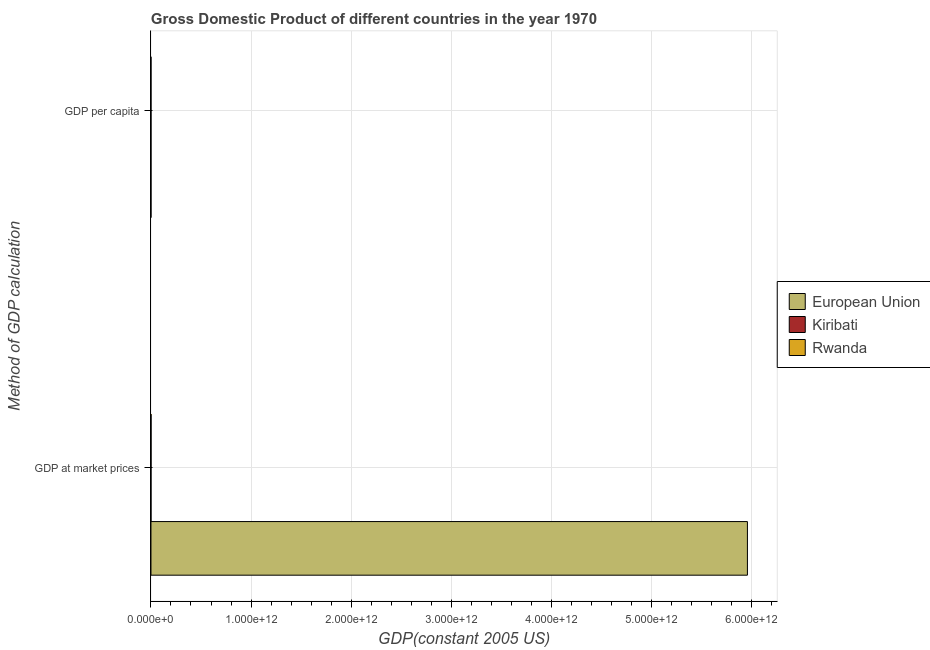How many bars are there on the 2nd tick from the top?
Ensure brevity in your answer.  3. How many bars are there on the 1st tick from the bottom?
Provide a succinct answer. 3. What is the label of the 1st group of bars from the top?
Make the answer very short. GDP per capita. What is the gdp at market prices in European Union?
Give a very brief answer. 5.96e+12. Across all countries, what is the maximum gdp per capita?
Offer a very short reply. 1.35e+04. Across all countries, what is the minimum gdp at market prices?
Your response must be concise. 8.36e+07. In which country was the gdp at market prices maximum?
Offer a terse response. European Union. In which country was the gdp per capita minimum?
Offer a terse response. Rwanda. What is the total gdp per capita in the graph?
Provide a short and direct response. 1.53e+04. What is the difference between the gdp at market prices in European Union and that in Rwanda?
Give a very brief answer. 5.96e+12. What is the difference between the gdp at market prices in European Union and the gdp per capita in Kiribati?
Make the answer very short. 5.96e+12. What is the average gdp at market prices per country?
Keep it short and to the point. 1.99e+12. What is the difference between the gdp per capita and gdp at market prices in Rwanda?
Your answer should be very brief. -8.41e+08. In how many countries, is the gdp per capita greater than 600000000000 US$?
Your response must be concise. 0. What is the ratio of the gdp at market prices in Kiribati to that in Rwanda?
Your answer should be very brief. 0.1. Is the gdp per capita in European Union less than that in Rwanda?
Offer a very short reply. No. What does the 1st bar from the top in GDP at market prices represents?
Make the answer very short. Rwanda. What does the 1st bar from the bottom in GDP at market prices represents?
Offer a terse response. European Union. How many countries are there in the graph?
Give a very brief answer. 3. What is the difference between two consecutive major ticks on the X-axis?
Your response must be concise. 1.00e+12. Are the values on the major ticks of X-axis written in scientific E-notation?
Offer a terse response. Yes. Where does the legend appear in the graph?
Provide a succinct answer. Center right. What is the title of the graph?
Keep it short and to the point. Gross Domestic Product of different countries in the year 1970. What is the label or title of the X-axis?
Provide a succinct answer. GDP(constant 2005 US). What is the label or title of the Y-axis?
Make the answer very short. Method of GDP calculation. What is the GDP(constant 2005 US) of European Union in GDP at market prices?
Your response must be concise. 5.96e+12. What is the GDP(constant 2005 US) in Kiribati in GDP at market prices?
Keep it short and to the point. 8.36e+07. What is the GDP(constant 2005 US) in Rwanda in GDP at market prices?
Offer a very short reply. 8.41e+08. What is the GDP(constant 2005 US) in European Union in GDP per capita?
Ensure brevity in your answer.  1.35e+04. What is the GDP(constant 2005 US) in Kiribati in GDP per capita?
Your response must be concise. 1633.14. What is the GDP(constant 2005 US) in Rwanda in GDP per capita?
Provide a succinct answer. 223.88. Across all Method of GDP calculation, what is the maximum GDP(constant 2005 US) in European Union?
Provide a short and direct response. 5.96e+12. Across all Method of GDP calculation, what is the maximum GDP(constant 2005 US) in Kiribati?
Offer a terse response. 8.36e+07. Across all Method of GDP calculation, what is the maximum GDP(constant 2005 US) in Rwanda?
Make the answer very short. 8.41e+08. Across all Method of GDP calculation, what is the minimum GDP(constant 2005 US) in European Union?
Offer a very short reply. 1.35e+04. Across all Method of GDP calculation, what is the minimum GDP(constant 2005 US) in Kiribati?
Your response must be concise. 1633.14. Across all Method of GDP calculation, what is the minimum GDP(constant 2005 US) in Rwanda?
Provide a succinct answer. 223.88. What is the total GDP(constant 2005 US) of European Union in the graph?
Your answer should be compact. 5.96e+12. What is the total GDP(constant 2005 US) of Kiribati in the graph?
Provide a succinct answer. 8.36e+07. What is the total GDP(constant 2005 US) in Rwanda in the graph?
Ensure brevity in your answer.  8.41e+08. What is the difference between the GDP(constant 2005 US) of European Union in GDP at market prices and that in GDP per capita?
Make the answer very short. 5.96e+12. What is the difference between the GDP(constant 2005 US) of Kiribati in GDP at market prices and that in GDP per capita?
Offer a terse response. 8.36e+07. What is the difference between the GDP(constant 2005 US) of Rwanda in GDP at market prices and that in GDP per capita?
Provide a short and direct response. 8.41e+08. What is the difference between the GDP(constant 2005 US) of European Union in GDP at market prices and the GDP(constant 2005 US) of Kiribati in GDP per capita?
Offer a terse response. 5.96e+12. What is the difference between the GDP(constant 2005 US) of European Union in GDP at market prices and the GDP(constant 2005 US) of Rwanda in GDP per capita?
Your answer should be very brief. 5.96e+12. What is the difference between the GDP(constant 2005 US) of Kiribati in GDP at market prices and the GDP(constant 2005 US) of Rwanda in GDP per capita?
Your answer should be compact. 8.36e+07. What is the average GDP(constant 2005 US) in European Union per Method of GDP calculation?
Make the answer very short. 2.98e+12. What is the average GDP(constant 2005 US) in Kiribati per Method of GDP calculation?
Offer a very short reply. 4.18e+07. What is the average GDP(constant 2005 US) in Rwanda per Method of GDP calculation?
Make the answer very short. 4.20e+08. What is the difference between the GDP(constant 2005 US) of European Union and GDP(constant 2005 US) of Kiribati in GDP at market prices?
Provide a succinct answer. 5.96e+12. What is the difference between the GDP(constant 2005 US) of European Union and GDP(constant 2005 US) of Rwanda in GDP at market prices?
Your response must be concise. 5.96e+12. What is the difference between the GDP(constant 2005 US) in Kiribati and GDP(constant 2005 US) in Rwanda in GDP at market prices?
Provide a short and direct response. -7.57e+08. What is the difference between the GDP(constant 2005 US) in European Union and GDP(constant 2005 US) in Kiribati in GDP per capita?
Ensure brevity in your answer.  1.19e+04. What is the difference between the GDP(constant 2005 US) in European Union and GDP(constant 2005 US) in Rwanda in GDP per capita?
Provide a short and direct response. 1.33e+04. What is the difference between the GDP(constant 2005 US) of Kiribati and GDP(constant 2005 US) of Rwanda in GDP per capita?
Provide a short and direct response. 1409.26. What is the ratio of the GDP(constant 2005 US) of European Union in GDP at market prices to that in GDP per capita?
Your response must be concise. 4.42e+08. What is the ratio of the GDP(constant 2005 US) in Kiribati in GDP at market prices to that in GDP per capita?
Give a very brief answer. 5.12e+04. What is the ratio of the GDP(constant 2005 US) of Rwanda in GDP at market prices to that in GDP per capita?
Your answer should be very brief. 3.75e+06. What is the difference between the highest and the second highest GDP(constant 2005 US) in European Union?
Your response must be concise. 5.96e+12. What is the difference between the highest and the second highest GDP(constant 2005 US) of Kiribati?
Keep it short and to the point. 8.36e+07. What is the difference between the highest and the second highest GDP(constant 2005 US) in Rwanda?
Make the answer very short. 8.41e+08. What is the difference between the highest and the lowest GDP(constant 2005 US) of European Union?
Your response must be concise. 5.96e+12. What is the difference between the highest and the lowest GDP(constant 2005 US) in Kiribati?
Provide a succinct answer. 8.36e+07. What is the difference between the highest and the lowest GDP(constant 2005 US) in Rwanda?
Make the answer very short. 8.41e+08. 